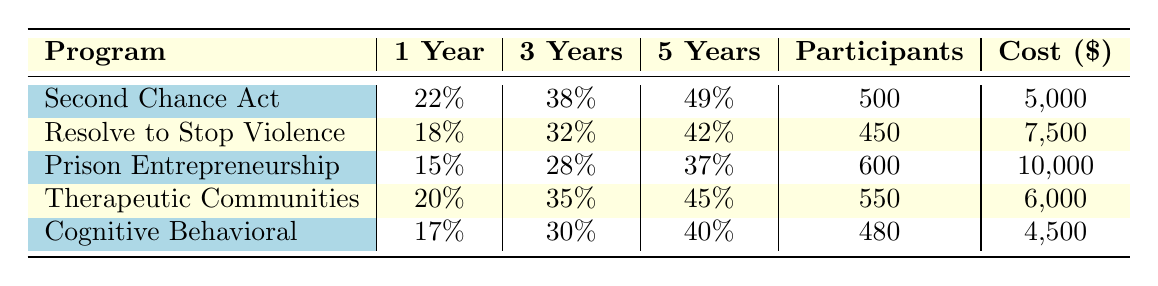What is the recidivism rate for the "Prison Entrepreneurship Program" after 3 years? According to the table, the recidivism rate for the "Prison Entrepreneurship Program" after 3 years is listed as 28%.
Answer: 28% Which rehabilitation program has the lowest recidivism rate after 1 year? From the table, the "Prison Entrepreneurship Program" has the lowest recidivism rate at 15% after 1 year.
Answer: Prison Entrepreneurship Program How many participants were involved in the "Therapeutic Communities" program? The table shows that there were 550 participants in the "Therapeutic Communities" program.
Answer: 550 What is the average recidivism rate after 5 years across all programs? To find the average, add the rates: (49 + 42 + 37 + 45 + 40) = 213, then divide by 5 (the number of programs), resulting in an average of 42.6%.
Answer: 42.6% Is the cost per participant for "Cognitive Behavioral Therapy" less than $5000? The cost per participant for "Cognitive Behavioral Therapy" is $4,500, which is less than $5,000.
Answer: Yes Which program has the highest recidivism rate after 5 years, and what is that rate? The "Second Chance Act" has the highest recidivism rate after 5 years, at 49%.
Answer: Second Chance Act, 49% What is the difference in the recidivism rate after 1 year between the "Resolve to Stop the Violence Project" and the "Therapeutic Communities"? The recidivism rate for "Resolve to Stop the Violence Project" after 1 year is 18%, and for "Therapeutic Communities", it is 20%. The difference is 20% - 18% = 2%.
Answer: 2% What is the program with the longest average duration, and how long is it? According to the table, the "Prison Entrepreneurship Program" has the longest average duration of 24 months.
Answer: Prison Entrepreneurship Program, 24 months If you combined the number of participants in "Second Chance Act" and "Cognitive Behavioral Therapy," how many participants would there be in total? The "Second Chance Act" had 500 participants, and "Cognitive Behavioral Therapy" had 480 participants. Combining these gives: 500 + 480 = 980 participants in total.
Answer: 980 Is the recidivism rate after 3 years for "Cognitive Behavioral Therapy" greater than the average of all programs? The average recidivism rate after 3 years from the programs (38 + 32 + 28 + 35 + 30 = 163) is 32.6%. "Cognitive Behavioral Therapy" has 30%, which is less than the average.
Answer: No 